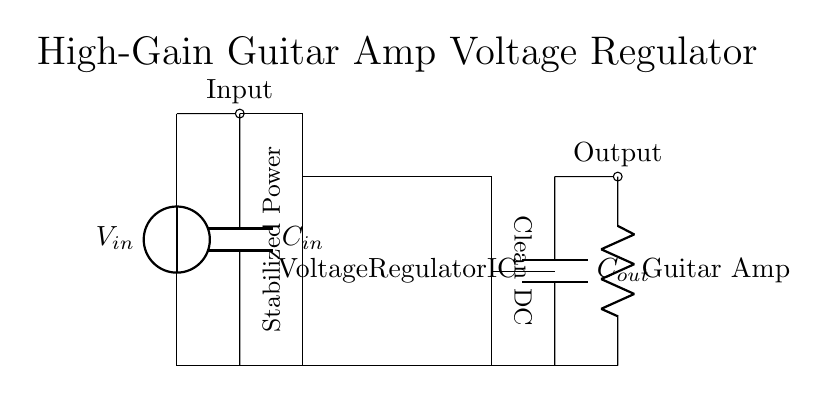What is the input voltage in the circuit? The input voltage is represented by the voltage source labeled V_in, and it is the initial voltage supplied to the circuit for regulation.
Answer: V_in What is the function of the capacitor labeled C_in? The capacitor C_in is used to stabilize the input voltage by smoothing any fluctuations before it reaches the voltage regulator IC, ensuring it operates effectively.
Answer: Stabilization How many capacitors are in the circuit? There are two capacitors present in the circuit: C_in at the input and C_out at the output, providing filtering at both ends.
Answer: Two What component receives the stabilized power supply? The stabilized power supply is provided to the load resistor labeled as Guitar Amp, which represents the high-gain amplifier in this circuit.
Answer: Guitar Amp What does the voltage regulator IC do in this circuit? The voltage regulator IC maintains a constant output voltage despite variations in the input voltage or load conditions, making it crucial for powering sensitive applications like guitar amplifiers.
Answer: Regulates voltage What is the purpose of the output capacitor C_out? The output capacitor C_out filters the output voltage to ensure a clean and stable DC supply to the load, minimizing ripple and noise for better amplifier performance.
Answer: Filtering What type of circuit is represented here? The circuit is a voltage regulator circuit specifically designed for stabilizing power supply to high-gain guitar amplifiers, which require precise voltage control for optimal performance.
Answer: Voltage regulator 